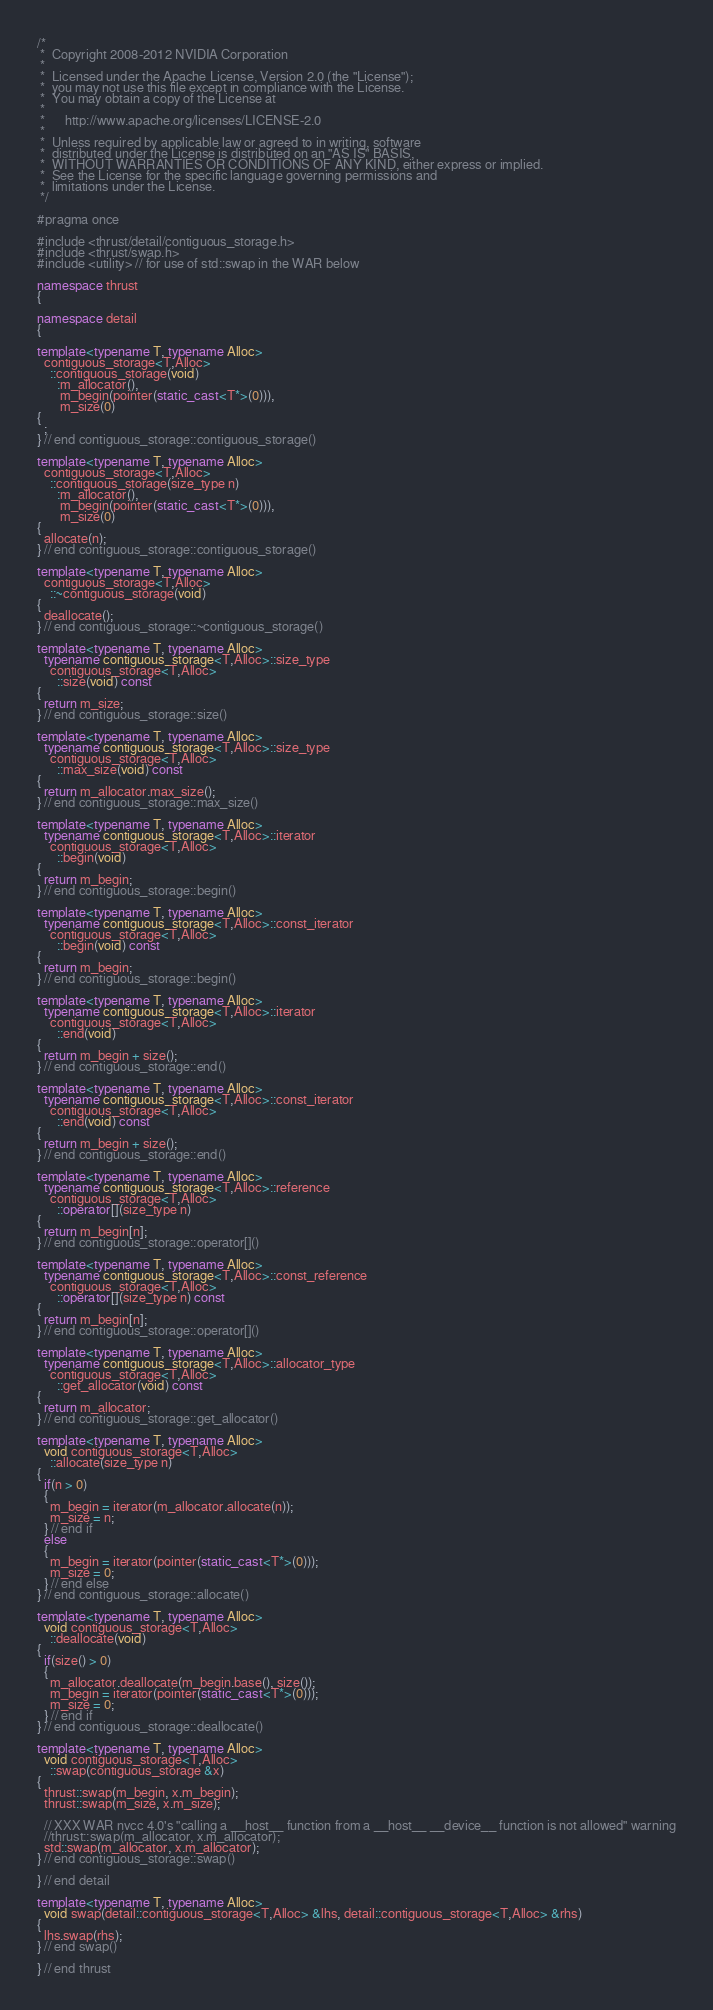Convert code to text. <code><loc_0><loc_0><loc_500><loc_500><_C++_>/*
 *  Copyright 2008-2012 NVIDIA Corporation
 *
 *  Licensed under the Apache License, Version 2.0 (the "License");
 *  you may not use this file except in compliance with the License.
 *  You may obtain a copy of the License at
 *
 *      http://www.apache.org/licenses/LICENSE-2.0
 *
 *  Unless required by applicable law or agreed to in writing, software
 *  distributed under the License is distributed on an "AS IS" BASIS,
 *  WITHOUT WARRANTIES OR CONDITIONS OF ANY KIND, either express or implied.
 *  See the License for the specific language governing permissions and
 *  limitations under the License.
 */

#pragma once

#include <thrust/detail/contiguous_storage.h>
#include <thrust/swap.h>
#include <utility> // for use of std::swap in the WAR below

namespace thrust
{

namespace detail
{

template<typename T, typename Alloc>
  contiguous_storage<T,Alloc>
    ::contiguous_storage(void)
      :m_allocator(),
       m_begin(pointer(static_cast<T*>(0))),
       m_size(0)
{
  ;
} // end contiguous_storage::contiguous_storage()

template<typename T, typename Alloc>
  contiguous_storage<T,Alloc>
    ::contiguous_storage(size_type n)
      :m_allocator(),
       m_begin(pointer(static_cast<T*>(0))),
       m_size(0)
{
  allocate(n);
} // end contiguous_storage::contiguous_storage()

template<typename T, typename Alloc>
  contiguous_storage<T,Alloc>
    ::~contiguous_storage(void)
{
  deallocate();
} // end contiguous_storage::~contiguous_storage()

template<typename T, typename Alloc>
  typename contiguous_storage<T,Alloc>::size_type
    contiguous_storage<T,Alloc>
      ::size(void) const
{
  return m_size;
} // end contiguous_storage::size()

template<typename T, typename Alloc>
  typename contiguous_storage<T,Alloc>::size_type
    contiguous_storage<T,Alloc>
      ::max_size(void) const
{
  return m_allocator.max_size();
} // end contiguous_storage::max_size()

template<typename T, typename Alloc>
  typename contiguous_storage<T,Alloc>::iterator
    contiguous_storage<T,Alloc>
      ::begin(void)
{
  return m_begin;
} // end contiguous_storage::begin()

template<typename T, typename Alloc>
  typename contiguous_storage<T,Alloc>::const_iterator
    contiguous_storage<T,Alloc>
      ::begin(void) const
{
  return m_begin;
} // end contiguous_storage::begin()

template<typename T, typename Alloc>
  typename contiguous_storage<T,Alloc>::iterator
    contiguous_storage<T,Alloc>
      ::end(void)
{
  return m_begin + size();
} // end contiguous_storage::end()

template<typename T, typename Alloc>
  typename contiguous_storage<T,Alloc>::const_iterator
    contiguous_storage<T,Alloc>
      ::end(void) const
{
  return m_begin + size();
} // end contiguous_storage::end()

template<typename T, typename Alloc>
  typename contiguous_storage<T,Alloc>::reference
    contiguous_storage<T,Alloc>
      ::operator[](size_type n)
{
  return m_begin[n];
} // end contiguous_storage::operator[]()

template<typename T, typename Alloc>
  typename contiguous_storage<T,Alloc>::const_reference
    contiguous_storage<T,Alloc>
      ::operator[](size_type n) const
{
  return m_begin[n];
} // end contiguous_storage::operator[]()

template<typename T, typename Alloc>
  typename contiguous_storage<T,Alloc>::allocator_type
    contiguous_storage<T,Alloc>
      ::get_allocator(void) const
{
  return m_allocator;
} // end contiguous_storage::get_allocator()

template<typename T, typename Alloc>
  void contiguous_storage<T,Alloc>
    ::allocate(size_type n)
{
  if(n > 0)
  {
    m_begin = iterator(m_allocator.allocate(n));
    m_size = n;
  } // end if
  else
  {
    m_begin = iterator(pointer(static_cast<T*>(0)));
    m_size = 0;
  } // end else
} // end contiguous_storage::allocate()

template<typename T, typename Alloc>
  void contiguous_storage<T,Alloc>
    ::deallocate(void)
{
  if(size() > 0)
  {
    m_allocator.deallocate(m_begin.base(), size());
    m_begin = iterator(pointer(static_cast<T*>(0)));
    m_size = 0;
  } // end if
} // end contiguous_storage::deallocate()

template<typename T, typename Alloc>
  void contiguous_storage<T,Alloc>
    ::swap(contiguous_storage &x)
{
  thrust::swap(m_begin, x.m_begin);
  thrust::swap(m_size, x.m_size);

  // XXX WAR nvcc 4.0's "calling a __host__ function from a __host__ __device__ function is not allowed" warning
  //thrust::swap(m_allocator, x.m_allocator);
  std::swap(m_allocator, x.m_allocator);
} // end contiguous_storage::swap()

} // end detail

template<typename T, typename Alloc>
  void swap(detail::contiguous_storage<T,Alloc> &lhs, detail::contiguous_storage<T,Alloc> &rhs)
{
  lhs.swap(rhs);
} // end swap()

} // end thrust

</code> 